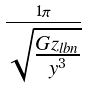Convert formula to latex. <formula><loc_0><loc_0><loc_500><loc_500>\frac { 1 \pi } { \sqrt { \frac { G z _ { l b n } } { y ^ { 3 } } } }</formula> 